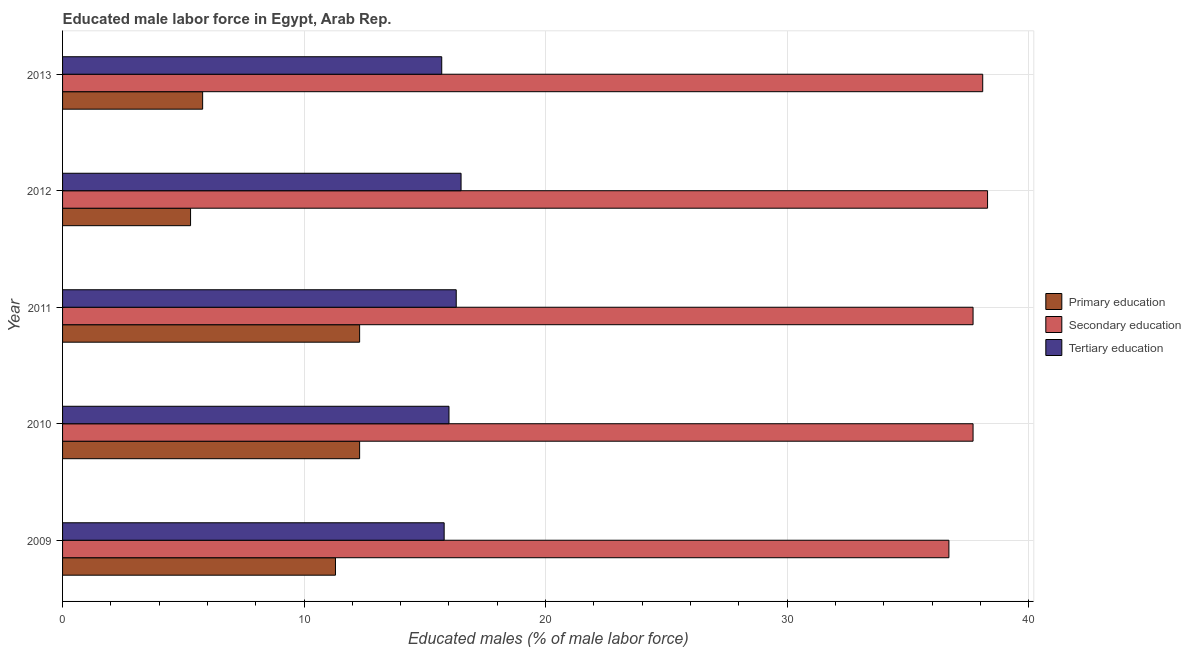How many different coloured bars are there?
Your answer should be compact. 3. How many groups of bars are there?
Your response must be concise. 5. Are the number of bars per tick equal to the number of legend labels?
Offer a very short reply. Yes. How many bars are there on the 2nd tick from the bottom?
Your response must be concise. 3. What is the label of the 3rd group of bars from the top?
Offer a terse response. 2011. What is the percentage of male labor force who received primary education in 2010?
Ensure brevity in your answer.  12.3. Across all years, what is the minimum percentage of male labor force who received tertiary education?
Offer a very short reply. 15.7. In which year was the percentage of male labor force who received primary education minimum?
Make the answer very short. 2012. What is the total percentage of male labor force who received primary education in the graph?
Your answer should be compact. 47. What is the difference between the percentage of male labor force who received primary education in 2010 and the percentage of male labor force who received secondary education in 2013?
Ensure brevity in your answer.  -25.8. What is the average percentage of male labor force who received secondary education per year?
Offer a terse response. 37.7. In the year 2009, what is the difference between the percentage of male labor force who received secondary education and percentage of male labor force who received primary education?
Keep it short and to the point. 25.4. Is the difference between the percentage of male labor force who received secondary education in 2009 and 2011 greater than the difference between the percentage of male labor force who received primary education in 2009 and 2011?
Your response must be concise. No. What is the difference between the highest and the lowest percentage of male labor force who received secondary education?
Ensure brevity in your answer.  1.6. Is the sum of the percentage of male labor force who received tertiary education in 2012 and 2013 greater than the maximum percentage of male labor force who received primary education across all years?
Keep it short and to the point. Yes. What does the 1st bar from the top in 2013 represents?
Make the answer very short. Tertiary education. What does the 2nd bar from the bottom in 2012 represents?
Your answer should be compact. Secondary education. How many bars are there?
Offer a terse response. 15. What is the difference between two consecutive major ticks on the X-axis?
Your answer should be compact. 10. Are the values on the major ticks of X-axis written in scientific E-notation?
Provide a succinct answer. No. Does the graph contain any zero values?
Offer a terse response. No. What is the title of the graph?
Your response must be concise. Educated male labor force in Egypt, Arab Rep. Does "Primary" appear as one of the legend labels in the graph?
Make the answer very short. No. What is the label or title of the X-axis?
Your answer should be very brief. Educated males (% of male labor force). What is the label or title of the Y-axis?
Provide a short and direct response. Year. What is the Educated males (% of male labor force) in Primary education in 2009?
Make the answer very short. 11.3. What is the Educated males (% of male labor force) of Secondary education in 2009?
Your answer should be very brief. 36.7. What is the Educated males (% of male labor force) in Tertiary education in 2009?
Make the answer very short. 15.8. What is the Educated males (% of male labor force) in Primary education in 2010?
Your answer should be compact. 12.3. What is the Educated males (% of male labor force) of Secondary education in 2010?
Give a very brief answer. 37.7. What is the Educated males (% of male labor force) in Tertiary education in 2010?
Provide a succinct answer. 16. What is the Educated males (% of male labor force) of Primary education in 2011?
Your answer should be very brief. 12.3. What is the Educated males (% of male labor force) in Secondary education in 2011?
Provide a short and direct response. 37.7. What is the Educated males (% of male labor force) in Tertiary education in 2011?
Keep it short and to the point. 16.3. What is the Educated males (% of male labor force) of Primary education in 2012?
Provide a succinct answer. 5.3. What is the Educated males (% of male labor force) in Secondary education in 2012?
Your answer should be compact. 38.3. What is the Educated males (% of male labor force) of Tertiary education in 2012?
Give a very brief answer. 16.5. What is the Educated males (% of male labor force) of Primary education in 2013?
Provide a succinct answer. 5.8. What is the Educated males (% of male labor force) of Secondary education in 2013?
Your answer should be compact. 38.1. What is the Educated males (% of male labor force) of Tertiary education in 2013?
Give a very brief answer. 15.7. Across all years, what is the maximum Educated males (% of male labor force) in Primary education?
Ensure brevity in your answer.  12.3. Across all years, what is the maximum Educated males (% of male labor force) of Secondary education?
Make the answer very short. 38.3. Across all years, what is the minimum Educated males (% of male labor force) in Primary education?
Your answer should be very brief. 5.3. Across all years, what is the minimum Educated males (% of male labor force) in Secondary education?
Your answer should be compact. 36.7. Across all years, what is the minimum Educated males (% of male labor force) of Tertiary education?
Give a very brief answer. 15.7. What is the total Educated males (% of male labor force) in Primary education in the graph?
Offer a very short reply. 47. What is the total Educated males (% of male labor force) in Secondary education in the graph?
Provide a succinct answer. 188.5. What is the total Educated males (% of male labor force) in Tertiary education in the graph?
Keep it short and to the point. 80.3. What is the difference between the Educated males (% of male labor force) in Primary education in 2009 and that in 2010?
Your answer should be very brief. -1. What is the difference between the Educated males (% of male labor force) of Secondary education in 2009 and that in 2011?
Offer a very short reply. -1. What is the difference between the Educated males (% of male labor force) of Tertiary education in 2009 and that in 2011?
Ensure brevity in your answer.  -0.5. What is the difference between the Educated males (% of male labor force) of Primary education in 2009 and that in 2012?
Provide a short and direct response. 6. What is the difference between the Educated males (% of male labor force) of Primary education in 2009 and that in 2013?
Keep it short and to the point. 5.5. What is the difference between the Educated males (% of male labor force) in Primary education in 2010 and that in 2011?
Offer a terse response. 0. What is the difference between the Educated males (% of male labor force) of Tertiary education in 2010 and that in 2011?
Provide a succinct answer. -0.3. What is the difference between the Educated males (% of male labor force) of Primary education in 2010 and that in 2012?
Ensure brevity in your answer.  7. What is the difference between the Educated males (% of male labor force) in Secondary education in 2010 and that in 2012?
Give a very brief answer. -0.6. What is the difference between the Educated males (% of male labor force) in Primary education in 2010 and that in 2013?
Make the answer very short. 6.5. What is the difference between the Educated males (% of male labor force) in Secondary education in 2010 and that in 2013?
Provide a short and direct response. -0.4. What is the difference between the Educated males (% of male labor force) in Tertiary education in 2010 and that in 2013?
Give a very brief answer. 0.3. What is the difference between the Educated males (% of male labor force) in Primary education in 2011 and that in 2013?
Ensure brevity in your answer.  6.5. What is the difference between the Educated males (% of male labor force) in Secondary education in 2011 and that in 2013?
Your answer should be compact. -0.4. What is the difference between the Educated males (% of male labor force) of Primary education in 2012 and that in 2013?
Your answer should be very brief. -0.5. What is the difference between the Educated males (% of male labor force) in Secondary education in 2012 and that in 2013?
Keep it short and to the point. 0.2. What is the difference between the Educated males (% of male labor force) in Tertiary education in 2012 and that in 2013?
Your response must be concise. 0.8. What is the difference between the Educated males (% of male labor force) in Primary education in 2009 and the Educated males (% of male labor force) in Secondary education in 2010?
Your response must be concise. -26.4. What is the difference between the Educated males (% of male labor force) of Secondary education in 2009 and the Educated males (% of male labor force) of Tertiary education in 2010?
Your answer should be compact. 20.7. What is the difference between the Educated males (% of male labor force) in Primary education in 2009 and the Educated males (% of male labor force) in Secondary education in 2011?
Your answer should be compact. -26.4. What is the difference between the Educated males (% of male labor force) of Primary education in 2009 and the Educated males (% of male labor force) of Tertiary education in 2011?
Give a very brief answer. -5. What is the difference between the Educated males (% of male labor force) of Secondary education in 2009 and the Educated males (% of male labor force) of Tertiary education in 2011?
Give a very brief answer. 20.4. What is the difference between the Educated males (% of male labor force) in Secondary education in 2009 and the Educated males (% of male labor force) in Tertiary education in 2012?
Your answer should be very brief. 20.2. What is the difference between the Educated males (% of male labor force) in Primary education in 2009 and the Educated males (% of male labor force) in Secondary education in 2013?
Your answer should be compact. -26.8. What is the difference between the Educated males (% of male labor force) of Secondary education in 2009 and the Educated males (% of male labor force) of Tertiary education in 2013?
Offer a terse response. 21. What is the difference between the Educated males (% of male labor force) in Primary education in 2010 and the Educated males (% of male labor force) in Secondary education in 2011?
Your answer should be compact. -25.4. What is the difference between the Educated males (% of male labor force) in Primary education in 2010 and the Educated males (% of male labor force) in Tertiary education in 2011?
Your answer should be very brief. -4. What is the difference between the Educated males (% of male labor force) in Secondary education in 2010 and the Educated males (% of male labor force) in Tertiary education in 2011?
Your answer should be very brief. 21.4. What is the difference between the Educated males (% of male labor force) in Primary education in 2010 and the Educated males (% of male labor force) in Secondary education in 2012?
Offer a very short reply. -26. What is the difference between the Educated males (% of male labor force) of Secondary education in 2010 and the Educated males (% of male labor force) of Tertiary education in 2012?
Ensure brevity in your answer.  21.2. What is the difference between the Educated males (% of male labor force) of Primary education in 2010 and the Educated males (% of male labor force) of Secondary education in 2013?
Make the answer very short. -25.8. What is the difference between the Educated males (% of male labor force) in Primary education in 2010 and the Educated males (% of male labor force) in Tertiary education in 2013?
Your answer should be very brief. -3.4. What is the difference between the Educated males (% of male labor force) of Primary education in 2011 and the Educated males (% of male labor force) of Secondary education in 2012?
Your answer should be very brief. -26. What is the difference between the Educated males (% of male labor force) in Primary education in 2011 and the Educated males (% of male labor force) in Tertiary education in 2012?
Provide a short and direct response. -4.2. What is the difference between the Educated males (% of male labor force) in Secondary education in 2011 and the Educated males (% of male labor force) in Tertiary education in 2012?
Keep it short and to the point. 21.2. What is the difference between the Educated males (% of male labor force) of Primary education in 2011 and the Educated males (% of male labor force) of Secondary education in 2013?
Make the answer very short. -25.8. What is the difference between the Educated males (% of male labor force) in Primary education in 2012 and the Educated males (% of male labor force) in Secondary education in 2013?
Give a very brief answer. -32.8. What is the difference between the Educated males (% of male labor force) in Secondary education in 2012 and the Educated males (% of male labor force) in Tertiary education in 2013?
Provide a succinct answer. 22.6. What is the average Educated males (% of male labor force) of Primary education per year?
Offer a terse response. 9.4. What is the average Educated males (% of male labor force) in Secondary education per year?
Your answer should be compact. 37.7. What is the average Educated males (% of male labor force) of Tertiary education per year?
Offer a very short reply. 16.06. In the year 2009, what is the difference between the Educated males (% of male labor force) in Primary education and Educated males (% of male labor force) in Secondary education?
Your answer should be very brief. -25.4. In the year 2009, what is the difference between the Educated males (% of male labor force) of Secondary education and Educated males (% of male labor force) of Tertiary education?
Your response must be concise. 20.9. In the year 2010, what is the difference between the Educated males (% of male labor force) in Primary education and Educated males (% of male labor force) in Secondary education?
Ensure brevity in your answer.  -25.4. In the year 2010, what is the difference between the Educated males (% of male labor force) of Primary education and Educated males (% of male labor force) of Tertiary education?
Give a very brief answer. -3.7. In the year 2010, what is the difference between the Educated males (% of male labor force) in Secondary education and Educated males (% of male labor force) in Tertiary education?
Offer a very short reply. 21.7. In the year 2011, what is the difference between the Educated males (% of male labor force) of Primary education and Educated males (% of male labor force) of Secondary education?
Make the answer very short. -25.4. In the year 2011, what is the difference between the Educated males (% of male labor force) in Primary education and Educated males (% of male labor force) in Tertiary education?
Make the answer very short. -4. In the year 2011, what is the difference between the Educated males (% of male labor force) of Secondary education and Educated males (% of male labor force) of Tertiary education?
Offer a terse response. 21.4. In the year 2012, what is the difference between the Educated males (% of male labor force) of Primary education and Educated males (% of male labor force) of Secondary education?
Make the answer very short. -33. In the year 2012, what is the difference between the Educated males (% of male labor force) in Secondary education and Educated males (% of male labor force) in Tertiary education?
Offer a very short reply. 21.8. In the year 2013, what is the difference between the Educated males (% of male labor force) of Primary education and Educated males (% of male labor force) of Secondary education?
Offer a terse response. -32.3. In the year 2013, what is the difference between the Educated males (% of male labor force) in Primary education and Educated males (% of male labor force) in Tertiary education?
Provide a short and direct response. -9.9. In the year 2013, what is the difference between the Educated males (% of male labor force) of Secondary education and Educated males (% of male labor force) of Tertiary education?
Your answer should be compact. 22.4. What is the ratio of the Educated males (% of male labor force) in Primary education in 2009 to that in 2010?
Your answer should be compact. 0.92. What is the ratio of the Educated males (% of male labor force) of Secondary education in 2009 to that in 2010?
Keep it short and to the point. 0.97. What is the ratio of the Educated males (% of male labor force) in Tertiary education in 2009 to that in 2010?
Give a very brief answer. 0.99. What is the ratio of the Educated males (% of male labor force) in Primary education in 2009 to that in 2011?
Provide a short and direct response. 0.92. What is the ratio of the Educated males (% of male labor force) of Secondary education in 2009 to that in 2011?
Offer a very short reply. 0.97. What is the ratio of the Educated males (% of male labor force) in Tertiary education in 2009 to that in 2011?
Ensure brevity in your answer.  0.97. What is the ratio of the Educated males (% of male labor force) of Primary education in 2009 to that in 2012?
Provide a succinct answer. 2.13. What is the ratio of the Educated males (% of male labor force) in Secondary education in 2009 to that in 2012?
Provide a succinct answer. 0.96. What is the ratio of the Educated males (% of male labor force) of Tertiary education in 2009 to that in 2012?
Your response must be concise. 0.96. What is the ratio of the Educated males (% of male labor force) in Primary education in 2009 to that in 2013?
Make the answer very short. 1.95. What is the ratio of the Educated males (% of male labor force) of Secondary education in 2009 to that in 2013?
Give a very brief answer. 0.96. What is the ratio of the Educated males (% of male labor force) in Tertiary education in 2009 to that in 2013?
Provide a short and direct response. 1.01. What is the ratio of the Educated males (% of male labor force) of Primary education in 2010 to that in 2011?
Your answer should be compact. 1. What is the ratio of the Educated males (% of male labor force) of Secondary education in 2010 to that in 2011?
Give a very brief answer. 1. What is the ratio of the Educated males (% of male labor force) in Tertiary education in 2010 to that in 2011?
Provide a short and direct response. 0.98. What is the ratio of the Educated males (% of male labor force) of Primary education in 2010 to that in 2012?
Ensure brevity in your answer.  2.32. What is the ratio of the Educated males (% of male labor force) in Secondary education in 2010 to that in 2012?
Your response must be concise. 0.98. What is the ratio of the Educated males (% of male labor force) of Tertiary education in 2010 to that in 2012?
Ensure brevity in your answer.  0.97. What is the ratio of the Educated males (% of male labor force) in Primary education in 2010 to that in 2013?
Your answer should be compact. 2.12. What is the ratio of the Educated males (% of male labor force) of Secondary education in 2010 to that in 2013?
Your answer should be compact. 0.99. What is the ratio of the Educated males (% of male labor force) in Tertiary education in 2010 to that in 2013?
Offer a terse response. 1.02. What is the ratio of the Educated males (% of male labor force) of Primary education in 2011 to that in 2012?
Offer a terse response. 2.32. What is the ratio of the Educated males (% of male labor force) of Secondary education in 2011 to that in 2012?
Your answer should be compact. 0.98. What is the ratio of the Educated males (% of male labor force) in Tertiary education in 2011 to that in 2012?
Make the answer very short. 0.99. What is the ratio of the Educated males (% of male labor force) in Primary education in 2011 to that in 2013?
Provide a succinct answer. 2.12. What is the ratio of the Educated males (% of male labor force) in Tertiary education in 2011 to that in 2013?
Make the answer very short. 1.04. What is the ratio of the Educated males (% of male labor force) of Primary education in 2012 to that in 2013?
Make the answer very short. 0.91. What is the ratio of the Educated males (% of male labor force) of Secondary education in 2012 to that in 2013?
Provide a succinct answer. 1.01. What is the ratio of the Educated males (% of male labor force) of Tertiary education in 2012 to that in 2013?
Make the answer very short. 1.05. What is the difference between the highest and the second highest Educated males (% of male labor force) of Primary education?
Provide a succinct answer. 0. What is the difference between the highest and the lowest Educated males (% of male labor force) in Secondary education?
Ensure brevity in your answer.  1.6. 